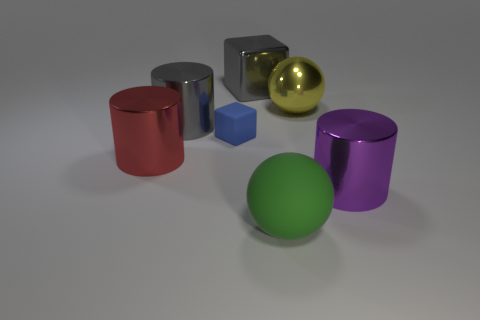The cube that is the same material as the yellow sphere is what color?
Keep it short and to the point. Gray. Are there fewer balls than small red metallic balls?
Keep it short and to the point. No. There is a thing that is both left of the large rubber object and behind the gray shiny cylinder; what is its material?
Ensure brevity in your answer.  Metal. There is a big sphere in front of the yellow sphere; are there any large yellow things behind it?
Make the answer very short. Yes. What number of metallic objects are the same color as the big shiny block?
Make the answer very short. 1. What material is the large cylinder that is the same color as the large block?
Offer a terse response. Metal. Does the yellow ball have the same material as the small blue thing?
Provide a succinct answer. No. Are there any yellow spheres in front of the big red metallic object?
Keep it short and to the point. No. What material is the large sphere right of the big ball in front of the small rubber object?
Your answer should be compact. Metal. What size is the other object that is the same shape as the large yellow metal thing?
Your answer should be compact. Large. 